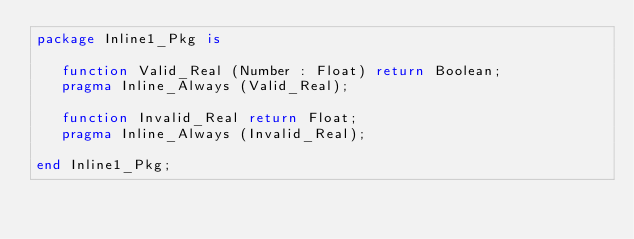Convert code to text. <code><loc_0><loc_0><loc_500><loc_500><_Ada_>package Inline1_Pkg is

   function Valid_Real (Number : Float) return Boolean;
   pragma Inline_Always (Valid_Real);

   function Invalid_Real return Float;
   pragma Inline_Always (Invalid_Real);

end Inline1_Pkg;
</code> 